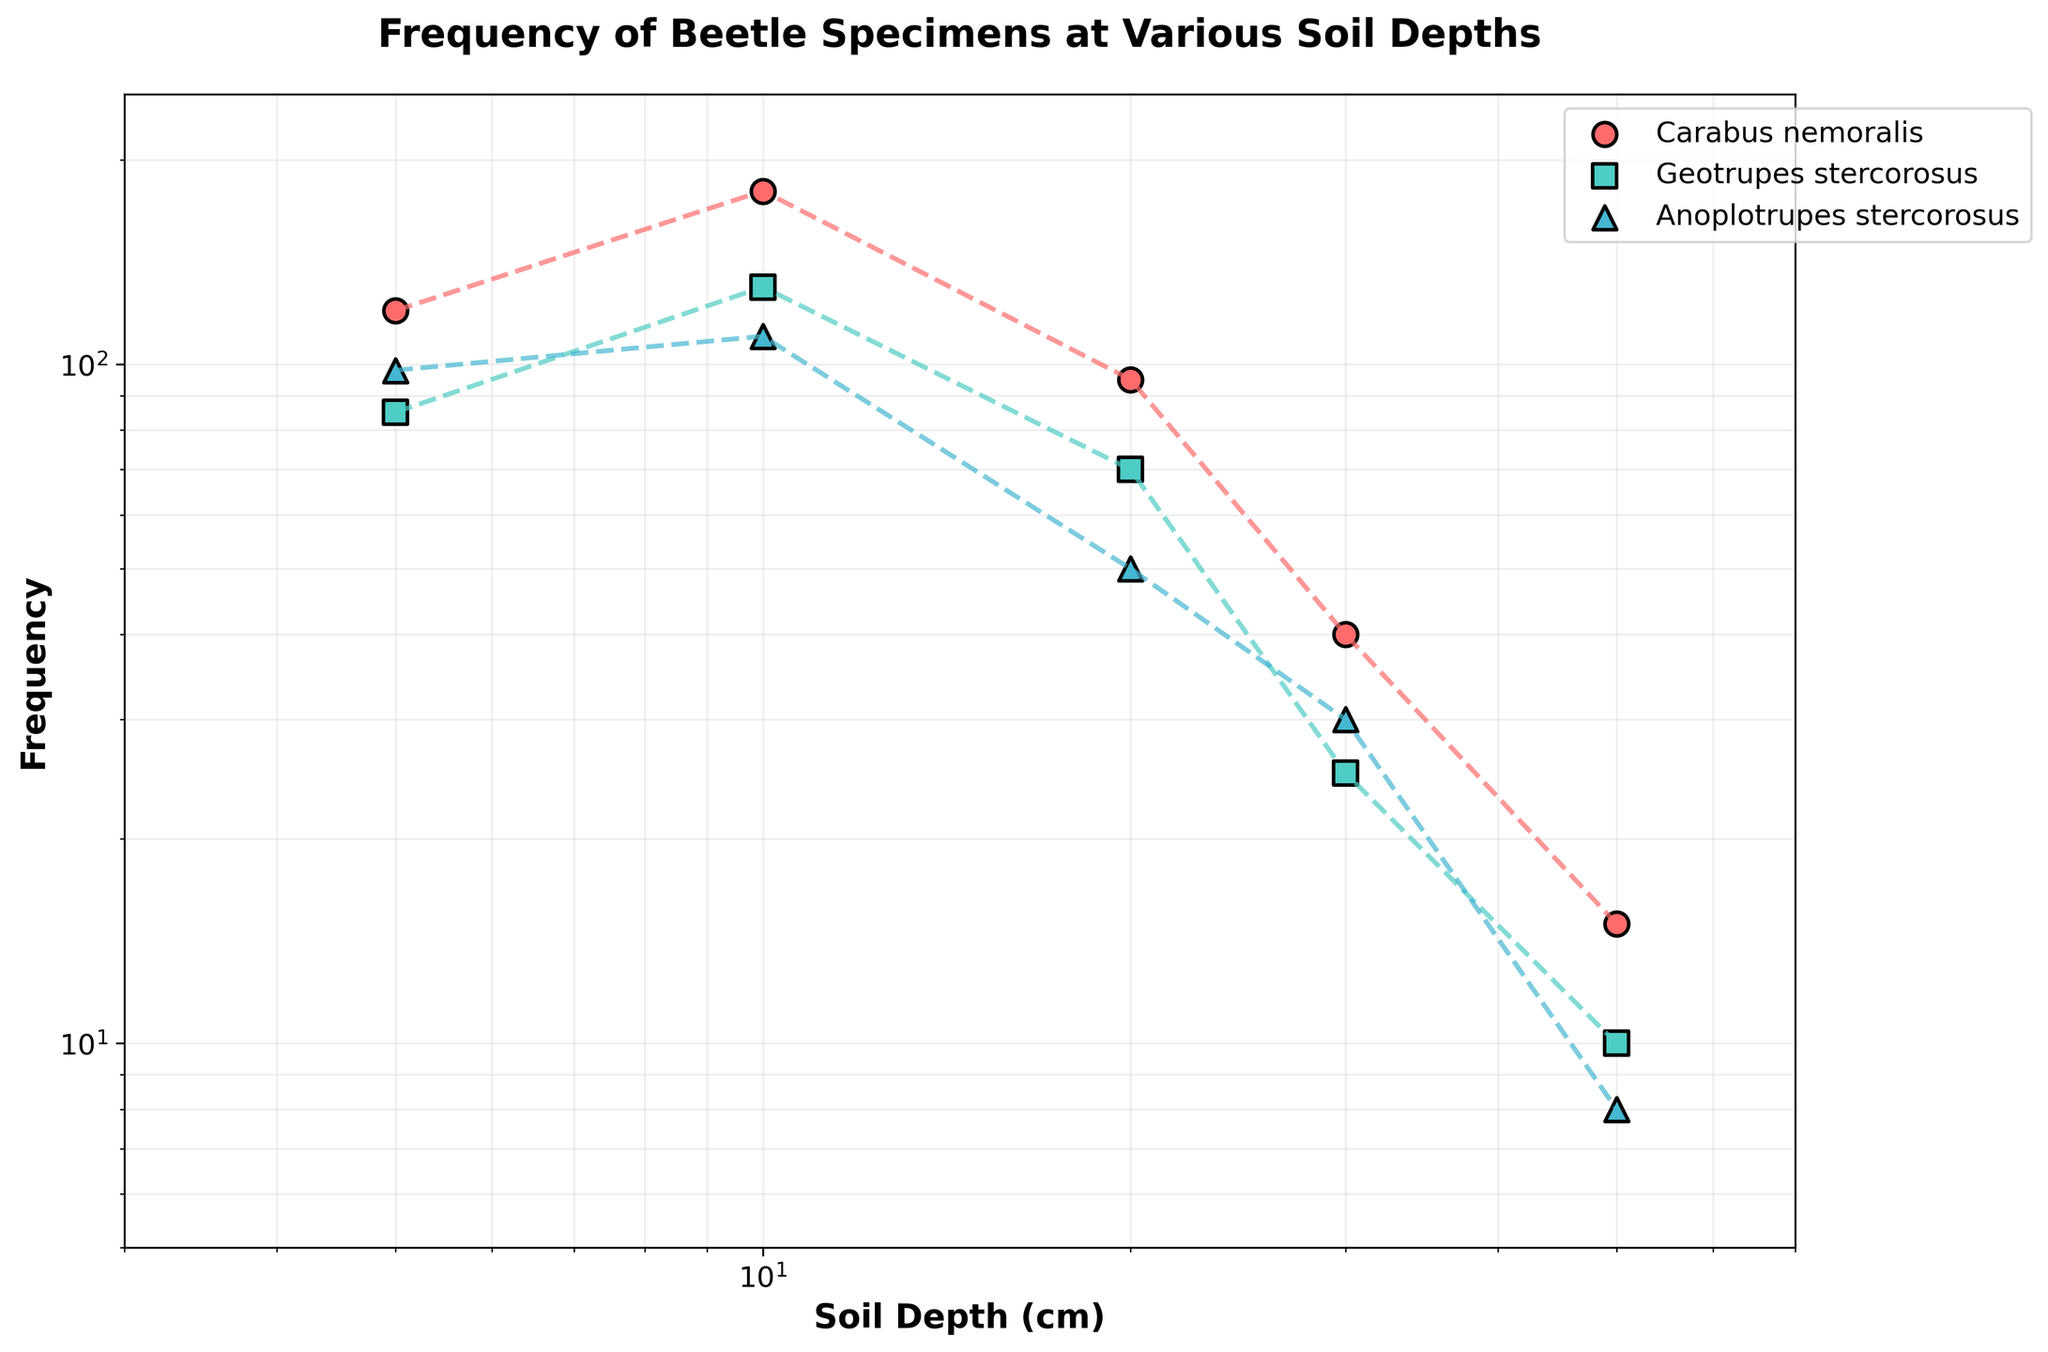What is the title of the plot? The title is located at the top center of the plot and provides an overview of what the plot represents.
Answer: Frequency of Beetle Specimens at Various Soil Depths How many beetle species are represented in the plot? The legend of the plot shows the different beetle species represented by different colors and markers.
Answer: 3 At which soil depth is the highest frequency of Carabus nemoralis observed? By following the trend line for Carabus nemoralis (marked with one color and style), the highest frequency value can be determined along the x-axis.
Answer: 10 cm Which beetle species has the lowest frequency at 50 cm soil depth? Check the points corresponding to the 50 cm soil depth on the x-axis and identify the one with the smallest y-value.
Answer: Anoplotrupes stercorosus What is the approximate frequency difference between Geotrupes stercorosus at 10 cm and 30 cm soil depth? Locate the frequency values for Geotrupes stercorosus at 10 cm and 30 cm on the y-axis, then calculate the difference.
Answer: 105 What type of scale is used on both axes of the plot? Both the x-axis and y-axis use a particular type of scale which can be observed in the uneven spacing of the points.
Answer: Logarithmic Comparing Carabus nemoralis and Anoplotrupes stercorosus at 20 cm soil depth, which one has a higher frequency, and by how much? Find the respective frequency values for both species at 20 cm soil depth and determine the difference.
Answer: Carabus nemoralis by 45 At which soil depth does Geotrupes stercorosus exhibit the highest frequency? Locate the highest point on the trend line for Geotrupes stercorosus and note the corresponding soil depth on the x-axis.
Answer: 10 cm What is the general trend of the frequency of Carabus nemoralis as soil depth increases from 5 cm to 50 cm? Describe the pattern of the data points and lines for Carabus nemoralis across increasing soil depths.
Answer: Decreasing Which beetle species shows the least variation in frequency across different soil depths? By comparing the trend lines and scattering for all species, the one with the smallest spread in frequency values will show the least variation.
Answer: Anoplotrupes stercorosus 